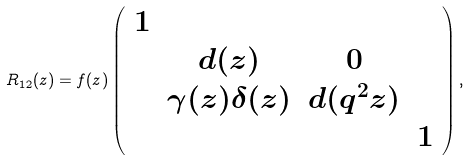Convert formula to latex. <formula><loc_0><loc_0><loc_500><loc_500>R _ { 1 2 } ( z ) = f ( z ) \left ( \begin{array} { c c c c } 1 & & & \\ & d ( z ) & 0 & \\ & \gamma ( z ) \delta ( z ) & d ( q ^ { 2 } z ) & \\ & & & 1 \end{array} \right ) ,</formula> 